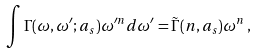Convert formula to latex. <formula><loc_0><loc_0><loc_500><loc_500>\int \Gamma ( \omega , \omega ^ { \prime } ; a _ { s } ) \omega ^ { \prime n } d \omega ^ { \prime } = \tilde { \Gamma } ( n , a _ { s } ) \omega ^ { n } \, ,</formula> 